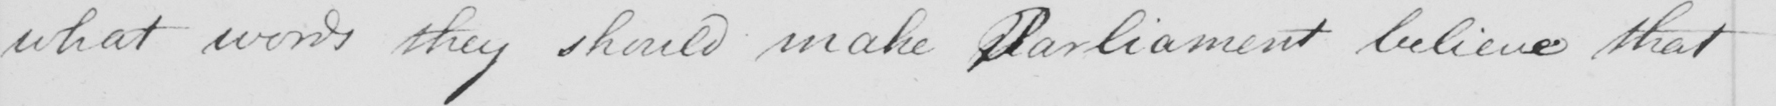Please transcribe the handwritten text in this image. what words they should make Parliament believe that 